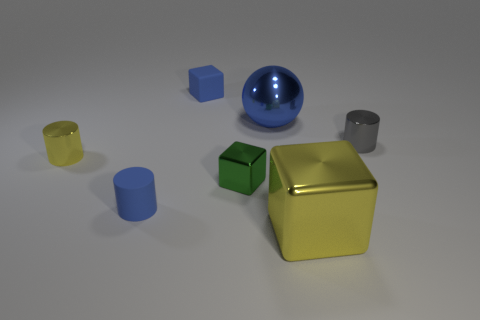There is a large metallic object that is the same color as the rubber cylinder; what shape is it?
Provide a short and direct response. Sphere. What size is the metallic ball that is the same color as the matte block?
Your response must be concise. Large. There is a large shiny block that is in front of the green shiny object that is in front of the large blue thing; what is its color?
Your answer should be compact. Yellow. What number of things are either tiny yellow metallic cylinders or things behind the blue metal ball?
Your answer should be very brief. 2. Is there a sphere that has the same color as the rubber cube?
Keep it short and to the point. Yes. What number of yellow things are matte cubes or big metallic objects?
Your answer should be compact. 1. How many other objects are there of the same size as the rubber cube?
Provide a short and direct response. 4. How many small objects are green metal things or spheres?
Ensure brevity in your answer.  1. Do the green object and the shiny cylinder that is to the left of the blue block have the same size?
Your answer should be compact. Yes. How many other objects are the same shape as the green metallic object?
Offer a terse response. 2. 